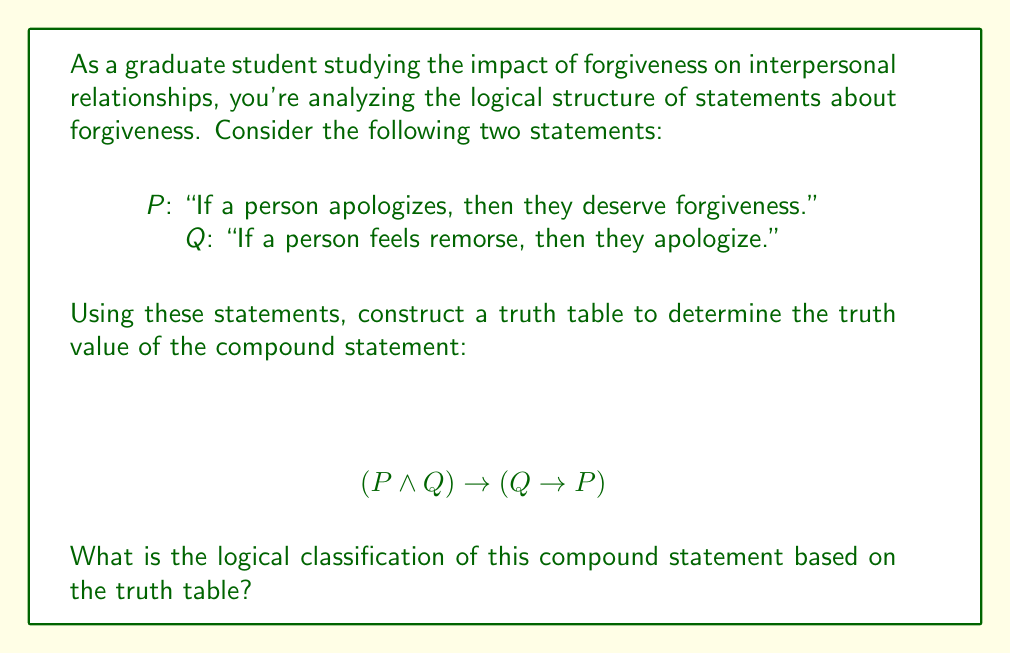Show me your answer to this math problem. Let's approach this step-by-step:

1) First, we need to identify the atomic propositions:
   P: "If a person apologizes, then they deserve forgiveness."
   Q: "If a person feels remorse, then they apologize."

2) Now, let's construct the truth table. We'll need columns for P, Q, $(P \wedge Q)$, $(Q \rightarrow P)$, and finally $(P \wedge Q) \rightarrow (Q \rightarrow P)$.

3) The truth table:

   | P | Q | $(P \wedge Q)$ | $(Q \rightarrow P)$ | $(P \wedge Q) \rightarrow (Q \rightarrow P)$ |
   |---|---|---------------|---------------------|-------------------------------------------|
   | T | T |       T       |         T           |                   T                       |
   | T | F |       F       |         T           |                   T                       |
   | F | T |       F       |         F           |                   T                       |
   | F | F |       F       |         T           |                   T                       |

4) Let's break down the last column:
   - When P and Q are both true, $(P \wedge Q)$ is true, and $(Q \rightarrow P)$ is true, so the implication is true.
   - When P is true and Q is false, $(P \wedge Q)$ is false, so the implication is automatically true (false implies anything is true).
   - When P is false and Q is true, $(P \wedge Q)$ is false, so the implication is true regardless of $(Q \rightarrow P)$.
   - When both P and Q are false, $(P \wedge Q)$ is false, so the implication is true.

5) We can see that the compound statement is true for all possible truth values of P and Q.

6) When a compound statement is true for all possible truth values of its atomic propositions, it is classified as a tautology.
Answer: Tautology 